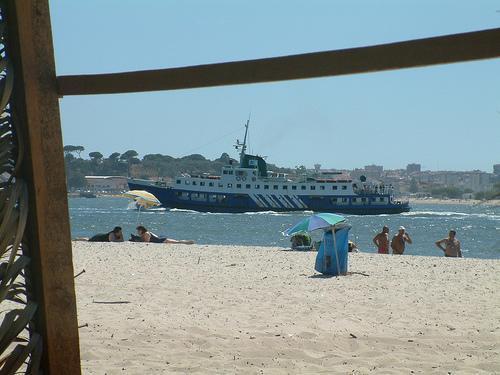How many people are visible on the sand?
Give a very brief answer. 5. How many beach umbrellas are visible?
Give a very brief answer. 2. How many boats are visible?
Give a very brief answer. 1. 